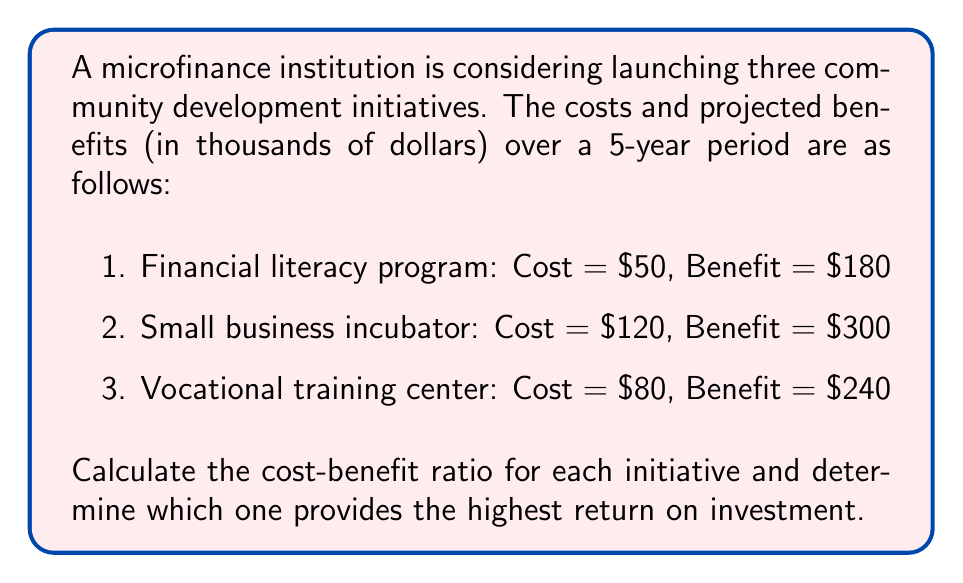Show me your answer to this math problem. To solve this problem, we need to calculate the cost-benefit ratio for each initiative and compare them. The cost-benefit ratio is calculated by dividing the total benefits by the total costs.

1. Financial literacy program:
   Cost-benefit ratio = $\frac{\text{Benefits}}{\text{Costs}} = \frac{180}{50} = 3.6$

2. Small business incubator:
   Cost-benefit ratio = $\frac{\text{Benefits}}{\text{Costs}} = \frac{300}{120} = 2.5$

3. Vocational training center:
   Cost-benefit ratio = $\frac{\text{Benefits}}{\text{Costs}} = \frac{240}{80} = 3$

To determine which initiative provides the highest return on investment, we compare the cost-benefit ratios:

Financial literacy program: 3.6
Small business incubator: 2.5
Vocational training center: 3

The highest cost-benefit ratio indicates the best return on investment. In this case, the financial literacy program has the highest ratio at 3.6, meaning it provides $3.60 in benefits for every $1 invested.
Answer: The financial literacy program provides the highest return on investment with a cost-benefit ratio of 3.6. 